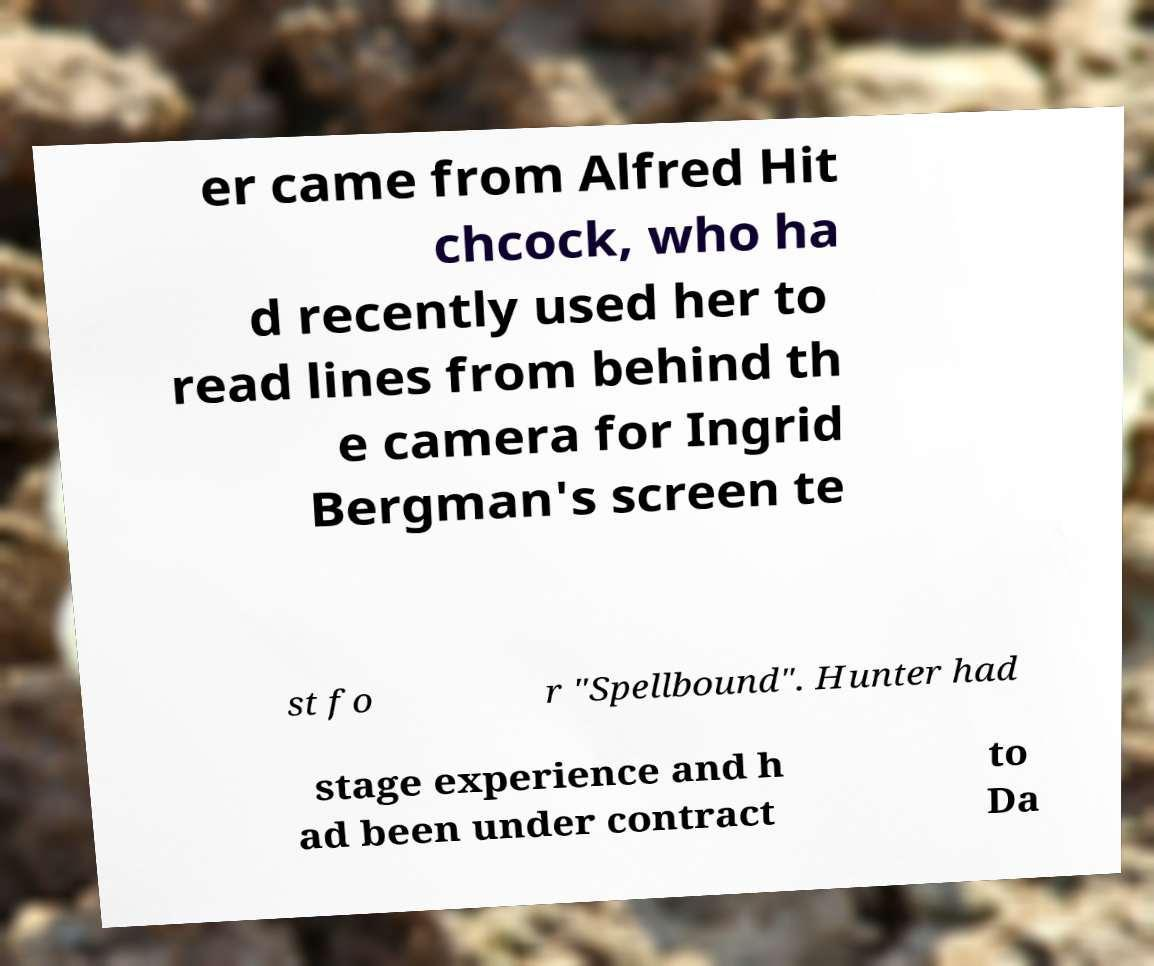Please read and relay the text visible in this image. What does it say? er came from Alfred Hit chcock, who ha d recently used her to read lines from behind th e camera for Ingrid Bergman's screen te st fo r "Spellbound". Hunter had stage experience and h ad been under contract to Da 